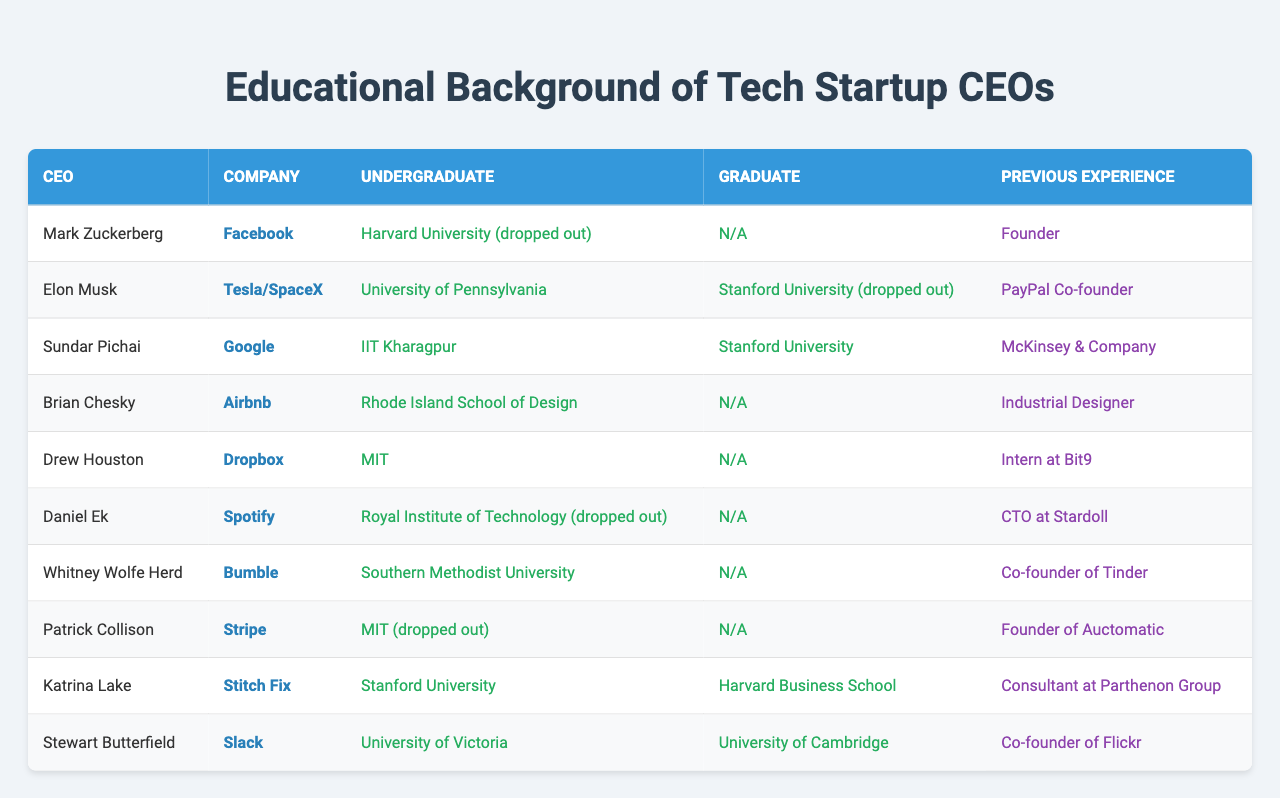What is the undergraduate degree of Elon Musk? From the table, locate the row for Elon Musk and see the value in the "Undergraduate" column. It states he attended the University of Pennsylvania.
Answer: University of Pennsylvania Which CEO graduated from Harvard Business School? Check the "Graduate" column for each CEO in the table to identify any associated with Harvard Business School. Katrina Lake is listed as having graduated from Harvard Business School.
Answer: Katrina Lake How many CEOs dropped out of their undergraduate programs? Reviewing the "Undergraduate" column, count the number of instances with "(dropped out)" next to the universities. There are four CEOs: Mark Zuckerberg, Daniel Ek, Patrick Collison, and Elon Musk.
Answer: 4 What is the previous experience of Sundar Pichai? Referencing the row for Sundar Pichai in the table, check the "Previous Experience" column to see that he worked at McKinsey & Company.
Answer: McKinsey & Company Did any CEO complete their graduate studies after attending Stanford University? Check the table for any CEOs who have "Stanford University" listed in their "Graduate" column. Only Sundar Pichai graduated from Stanford, while Elon Musk dropped out from it. Therefore, Sundar Pichai is the only one who completed his studies.
Answer: Yes Which company is associated with the CEO who studied at the Royal Institute of Technology? Look at the row where the "Undergraduate" column mentions the Royal Institute of Technology, which corresponds to Daniel Ek, CEO of Spotify.
Answer: Spotify What percentage of the CEOs listed have a background in MIT for their undergraduate studies? There are 10 CEOs in total, and 2 of them studied at MIT (Drew Houston and Patrick Collison). To find the percentage, divide 2 by 10 and multiply by 100, which equals 20%.
Answer: 20% Is there any CEO with an undergraduate background from a design school? Observing the data in the "Undergraduate" column, Brian Chesky is the only CEO from the Rhode Island School of Design, fulfilling this criterion.
Answer: Yes What is the graduate school background of Whitney Wolfe Herd? Review Whitney Wolfe Herd's row in the table; she does not have a graduate education listed, signifying "N/A" under the "Graduate" column.
Answer: N/A Which CEO has the most diverse previous experience according to the table? Analyze the "Previous Experience" column for breadth of experience. Mark Zuckerberg is noted simply as "Founder," while CEOs like Patrick Collison and Whitney Wolfe Herd have roles in multiple companies (Auctomatic and Tinder, respectively), indicating diverse backgrounds. Thus, Whitney Wolfe Herd might qualify due to co-founding two significant companies.
Answer: Whitney Wolfe Herd 